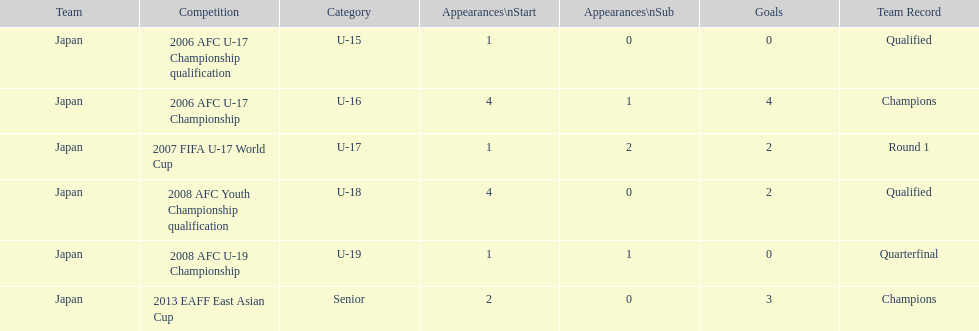Would you be able to parse every entry in this table? {'header': ['Team', 'Competition', 'Category', 'Appearances\\nStart', 'Appearances\\nSub', 'Goals', 'Team Record'], 'rows': [['Japan', '2006 AFC U-17 Championship qualification', 'U-15', '1', '0', '0', 'Qualified'], ['Japan', '2006 AFC U-17 Championship', 'U-16', '4', '1', '4', 'Champions'], ['Japan', '2007 FIFA U-17 World Cup', 'U-17', '1', '2', '2', 'Round 1'], ['Japan', '2008 AFC Youth Championship qualification', 'U-18', '4', '0', '2', 'Qualified'], ['Japan', '2008 AFC U-19 Championship', 'U-19', '1', '1', '0', 'Quarterfinal'], ['Japan', '2013 EAFF East Asian Cup', 'Senior', '2', '0', '3', 'Champions']]} Name the earliest competition to have a sub. 2006 AFC U-17 Championship. 